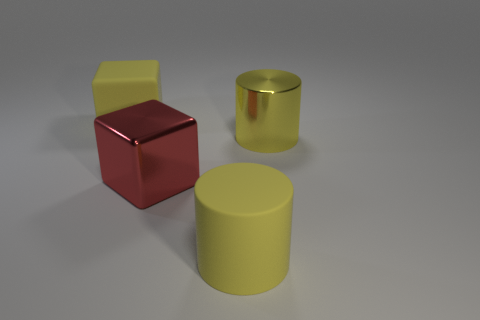What size is the metal thing that is the same color as the matte cylinder?
Make the answer very short. Large. What number of matte objects have the same color as the metal cylinder?
Offer a terse response. 2. The big red thing has what shape?
Make the answer very short. Cube. There is a big object that is both behind the big metal cube and to the left of the large metal cylinder; what is its color?
Make the answer very short. Yellow. What is the material of the large red cube?
Provide a short and direct response. Metal. What is the shape of the shiny object that is to the left of the yellow metal thing?
Keep it short and to the point. Cube. The metal cube that is the same size as the metal cylinder is what color?
Offer a very short reply. Red. Are the big thing on the left side of the big red block and the red object made of the same material?
Provide a short and direct response. No. There is a yellow object that is both behind the yellow matte cylinder and on the right side of the large rubber block; what is its size?
Ensure brevity in your answer.  Large. There is a metal thing that is in front of the metallic cylinder; what size is it?
Offer a very short reply. Large. 